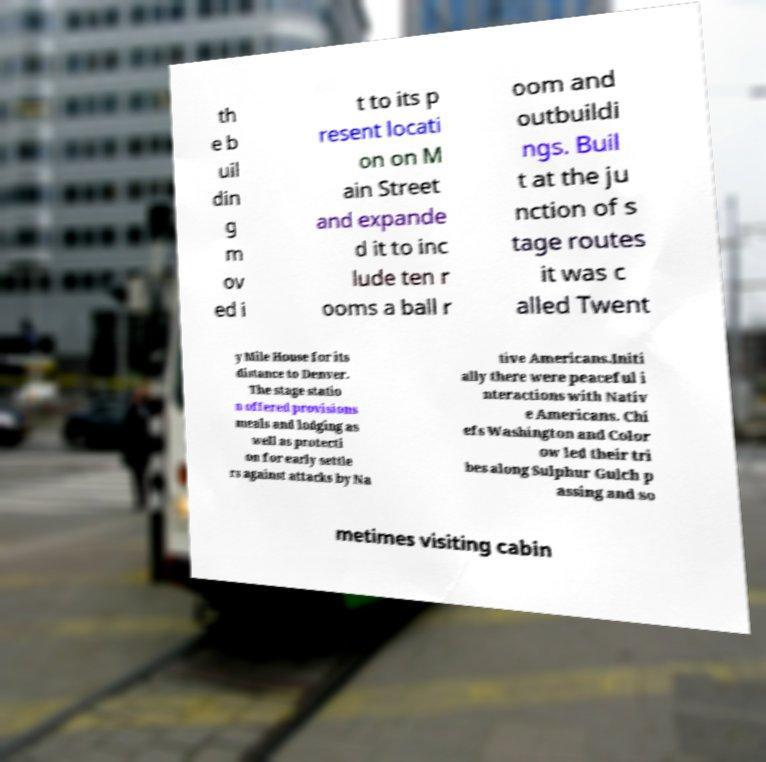Please identify and transcribe the text found in this image. th e b uil din g m ov ed i t to its p resent locati on on M ain Street and expande d it to inc lude ten r ooms a ball r oom and outbuildi ngs. Buil t at the ju nction of s tage routes it was c alled Twent y Mile House for its distance to Denver. The stage statio n offered provisions meals and lodging as well as protecti on for early settle rs against attacks by Na tive Americans.Initi ally there were peaceful i nteractions with Nativ e Americans. Chi efs Washington and Color ow led their tri bes along Sulphur Gulch p assing and so metimes visiting cabin 